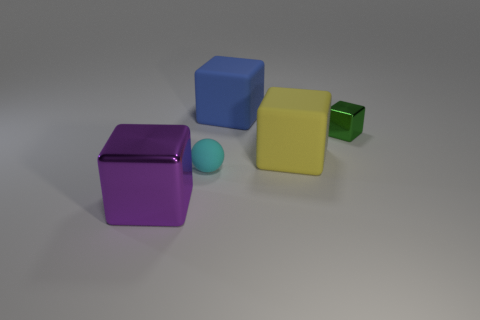Are there fewer small rubber balls that are behind the ball than tiny shiny blocks?
Ensure brevity in your answer.  Yes. There is a metal thing that is behind the thing left of the small thing in front of the tiny green cube; what shape is it?
Make the answer very short. Cube. Do the big purple metallic thing and the yellow rubber thing have the same shape?
Make the answer very short. Yes. What number of other things are the same shape as the big yellow object?
Give a very brief answer. 3. What is the color of the rubber block that is the same size as the blue rubber thing?
Keep it short and to the point. Yellow. Are there the same number of small things on the left side of the large yellow object and purple objects?
Provide a succinct answer. Yes. What is the shape of the matte object that is to the left of the yellow rubber cube and in front of the tiny green shiny block?
Provide a short and direct response. Sphere. Is the size of the blue block the same as the cyan rubber object?
Your response must be concise. No. Is there a small sphere that has the same material as the big yellow block?
Make the answer very short. Yes. What number of tiny things are both right of the blue matte block and in front of the tiny green metal thing?
Your response must be concise. 0. 